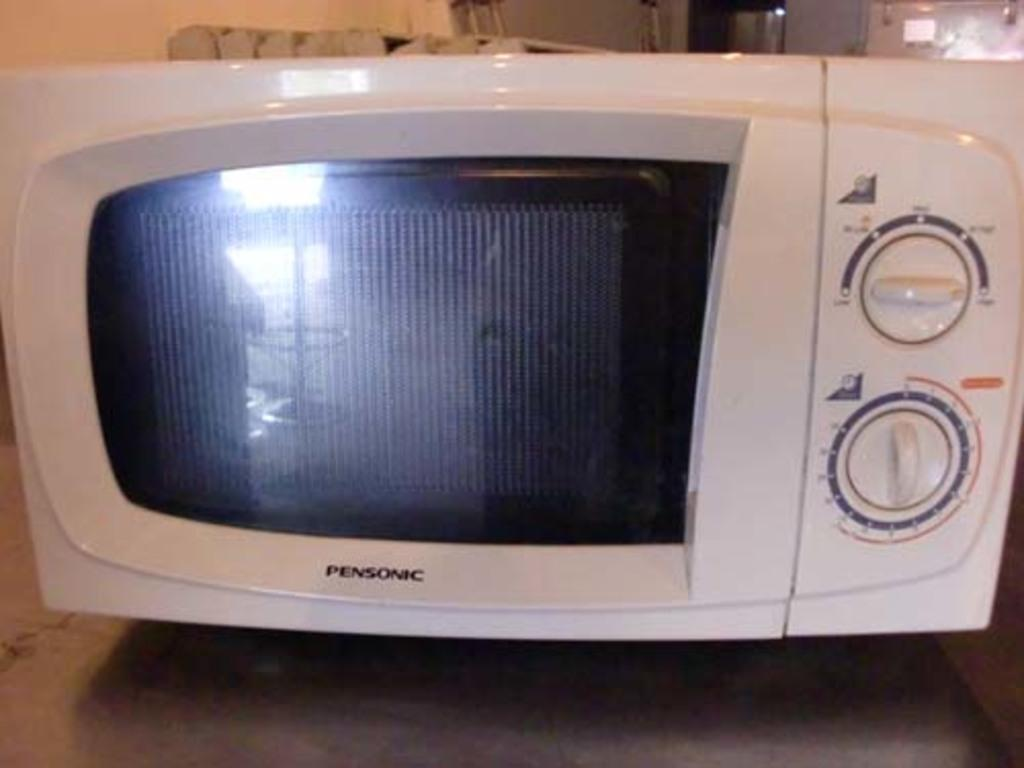<image>
Present a compact description of the photo's key features. a microwave that has the word Pensonic on it 